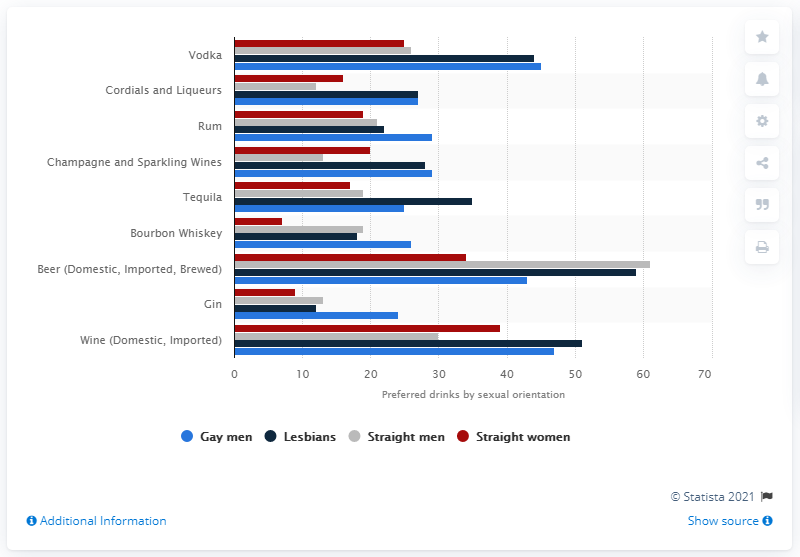How do the preferences for tequila vary by sexual orientation? The data indicates that tequila is preferred by about 27% of gay men and 25% of lesbians, which is slightly higher than the preferences shown by straight men (around 20%) and straight women (approximately 23%). This suggests a slightly higher favorability of tequila among homosexual demographics. 